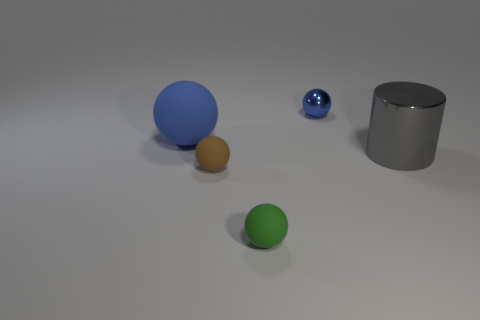Is there any indication of the objects' sizes relative to each other? Yes, the objects are of different sizes with the blue sphere being the largest and the blue marble-size sphere being the smallest. The relative sizes suggest a diminution from the left to the right. 